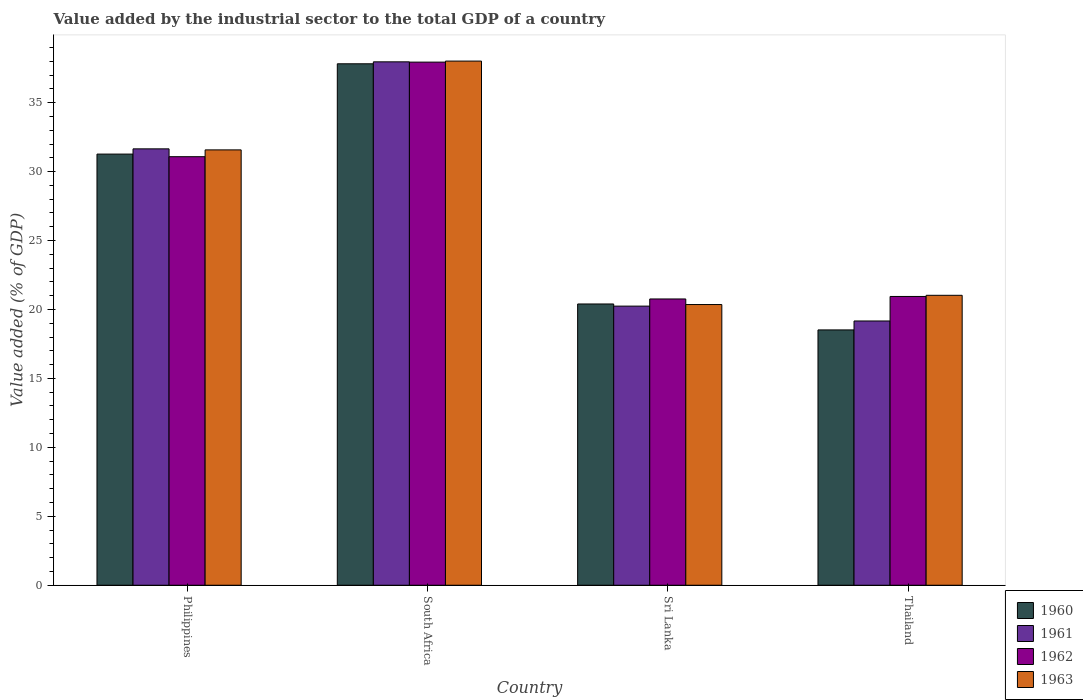How many different coloured bars are there?
Ensure brevity in your answer.  4. How many groups of bars are there?
Provide a succinct answer. 4. Are the number of bars per tick equal to the number of legend labels?
Offer a very short reply. Yes. Are the number of bars on each tick of the X-axis equal?
Your answer should be compact. Yes. What is the label of the 4th group of bars from the left?
Provide a succinct answer. Thailand. What is the value added by the industrial sector to the total GDP in 1962 in Thailand?
Offer a terse response. 20.94. Across all countries, what is the maximum value added by the industrial sector to the total GDP in 1963?
Your answer should be very brief. 38.01. Across all countries, what is the minimum value added by the industrial sector to the total GDP in 1963?
Your response must be concise. 20.36. In which country was the value added by the industrial sector to the total GDP in 1962 maximum?
Offer a very short reply. South Africa. In which country was the value added by the industrial sector to the total GDP in 1962 minimum?
Make the answer very short. Sri Lanka. What is the total value added by the industrial sector to the total GDP in 1963 in the graph?
Offer a terse response. 110.97. What is the difference between the value added by the industrial sector to the total GDP in 1960 in Philippines and that in South Africa?
Keep it short and to the point. -6.55. What is the difference between the value added by the industrial sector to the total GDP in 1960 in South Africa and the value added by the industrial sector to the total GDP in 1962 in Sri Lanka?
Offer a very short reply. 17.06. What is the average value added by the industrial sector to the total GDP in 1960 per country?
Offer a very short reply. 27. What is the difference between the value added by the industrial sector to the total GDP of/in 1962 and value added by the industrial sector to the total GDP of/in 1960 in Thailand?
Make the answer very short. 2.43. What is the ratio of the value added by the industrial sector to the total GDP in 1963 in South Africa to that in Thailand?
Offer a very short reply. 1.81. Is the value added by the industrial sector to the total GDP in 1960 in Philippines less than that in Sri Lanka?
Your response must be concise. No. Is the difference between the value added by the industrial sector to the total GDP in 1962 in Philippines and Thailand greater than the difference between the value added by the industrial sector to the total GDP in 1960 in Philippines and Thailand?
Offer a terse response. No. What is the difference between the highest and the second highest value added by the industrial sector to the total GDP in 1963?
Keep it short and to the point. -16.99. What is the difference between the highest and the lowest value added by the industrial sector to the total GDP in 1960?
Keep it short and to the point. 19.3. In how many countries, is the value added by the industrial sector to the total GDP in 1960 greater than the average value added by the industrial sector to the total GDP in 1960 taken over all countries?
Your answer should be very brief. 2. What does the 3rd bar from the right in Thailand represents?
Provide a short and direct response. 1961. Are all the bars in the graph horizontal?
Offer a very short reply. No. How many countries are there in the graph?
Offer a very short reply. 4. What is the difference between two consecutive major ticks on the Y-axis?
Your answer should be very brief. 5. Are the values on the major ticks of Y-axis written in scientific E-notation?
Offer a very short reply. No. Does the graph contain grids?
Ensure brevity in your answer.  No. How are the legend labels stacked?
Give a very brief answer. Vertical. What is the title of the graph?
Make the answer very short. Value added by the industrial sector to the total GDP of a country. Does "1968" appear as one of the legend labels in the graph?
Keep it short and to the point. No. What is the label or title of the X-axis?
Offer a very short reply. Country. What is the label or title of the Y-axis?
Give a very brief answer. Value added (% of GDP). What is the Value added (% of GDP) in 1960 in Philippines?
Provide a succinct answer. 31.27. What is the Value added (% of GDP) of 1961 in Philippines?
Offer a terse response. 31.65. What is the Value added (% of GDP) in 1962 in Philippines?
Offer a very short reply. 31.08. What is the Value added (% of GDP) of 1963 in Philippines?
Offer a terse response. 31.57. What is the Value added (% of GDP) of 1960 in South Africa?
Provide a succinct answer. 37.82. What is the Value added (% of GDP) of 1961 in South Africa?
Offer a very short reply. 37.96. What is the Value added (% of GDP) in 1962 in South Africa?
Provide a short and direct response. 37.94. What is the Value added (% of GDP) in 1963 in South Africa?
Provide a succinct answer. 38.01. What is the Value added (% of GDP) in 1960 in Sri Lanka?
Your answer should be very brief. 20.4. What is the Value added (% of GDP) of 1961 in Sri Lanka?
Your answer should be very brief. 20.24. What is the Value added (% of GDP) in 1962 in Sri Lanka?
Keep it short and to the point. 20.76. What is the Value added (% of GDP) in 1963 in Sri Lanka?
Keep it short and to the point. 20.36. What is the Value added (% of GDP) in 1960 in Thailand?
Keep it short and to the point. 18.52. What is the Value added (% of GDP) of 1961 in Thailand?
Make the answer very short. 19.16. What is the Value added (% of GDP) of 1962 in Thailand?
Offer a very short reply. 20.94. What is the Value added (% of GDP) in 1963 in Thailand?
Your answer should be very brief. 21.03. Across all countries, what is the maximum Value added (% of GDP) in 1960?
Ensure brevity in your answer.  37.82. Across all countries, what is the maximum Value added (% of GDP) of 1961?
Your answer should be very brief. 37.96. Across all countries, what is the maximum Value added (% of GDP) in 1962?
Your answer should be very brief. 37.94. Across all countries, what is the maximum Value added (% of GDP) in 1963?
Ensure brevity in your answer.  38.01. Across all countries, what is the minimum Value added (% of GDP) of 1960?
Provide a short and direct response. 18.52. Across all countries, what is the minimum Value added (% of GDP) of 1961?
Your response must be concise. 19.16. Across all countries, what is the minimum Value added (% of GDP) of 1962?
Give a very brief answer. 20.76. Across all countries, what is the minimum Value added (% of GDP) of 1963?
Ensure brevity in your answer.  20.36. What is the total Value added (% of GDP) in 1960 in the graph?
Offer a terse response. 108. What is the total Value added (% of GDP) in 1961 in the graph?
Provide a succinct answer. 109.02. What is the total Value added (% of GDP) in 1962 in the graph?
Your answer should be compact. 110.72. What is the total Value added (% of GDP) in 1963 in the graph?
Provide a short and direct response. 110.97. What is the difference between the Value added (% of GDP) of 1960 in Philippines and that in South Africa?
Keep it short and to the point. -6.55. What is the difference between the Value added (% of GDP) in 1961 in Philippines and that in South Africa?
Give a very brief answer. -6.31. What is the difference between the Value added (% of GDP) in 1962 in Philippines and that in South Africa?
Your answer should be compact. -6.86. What is the difference between the Value added (% of GDP) of 1963 in Philippines and that in South Africa?
Your answer should be very brief. -6.44. What is the difference between the Value added (% of GDP) in 1960 in Philippines and that in Sri Lanka?
Provide a succinct answer. 10.87. What is the difference between the Value added (% of GDP) in 1961 in Philippines and that in Sri Lanka?
Give a very brief answer. 11.41. What is the difference between the Value added (% of GDP) of 1962 in Philippines and that in Sri Lanka?
Provide a short and direct response. 10.32. What is the difference between the Value added (% of GDP) in 1963 in Philippines and that in Sri Lanka?
Your answer should be very brief. 11.22. What is the difference between the Value added (% of GDP) of 1960 in Philippines and that in Thailand?
Keep it short and to the point. 12.75. What is the difference between the Value added (% of GDP) in 1961 in Philippines and that in Thailand?
Your response must be concise. 12.48. What is the difference between the Value added (% of GDP) in 1962 in Philippines and that in Thailand?
Your response must be concise. 10.14. What is the difference between the Value added (% of GDP) of 1963 in Philippines and that in Thailand?
Ensure brevity in your answer.  10.55. What is the difference between the Value added (% of GDP) in 1960 in South Africa and that in Sri Lanka?
Provide a succinct answer. 17.42. What is the difference between the Value added (% of GDP) in 1961 in South Africa and that in Sri Lanka?
Provide a succinct answer. 17.72. What is the difference between the Value added (% of GDP) in 1962 in South Africa and that in Sri Lanka?
Offer a terse response. 17.18. What is the difference between the Value added (% of GDP) in 1963 in South Africa and that in Sri Lanka?
Keep it short and to the point. 17.66. What is the difference between the Value added (% of GDP) of 1960 in South Africa and that in Thailand?
Offer a terse response. 19.3. What is the difference between the Value added (% of GDP) of 1961 in South Africa and that in Thailand?
Offer a terse response. 18.79. What is the difference between the Value added (% of GDP) in 1962 in South Africa and that in Thailand?
Make the answer very short. 17. What is the difference between the Value added (% of GDP) in 1963 in South Africa and that in Thailand?
Offer a terse response. 16.99. What is the difference between the Value added (% of GDP) in 1960 in Sri Lanka and that in Thailand?
Your response must be concise. 1.88. What is the difference between the Value added (% of GDP) in 1961 in Sri Lanka and that in Thailand?
Offer a very short reply. 1.08. What is the difference between the Value added (% of GDP) in 1962 in Sri Lanka and that in Thailand?
Provide a succinct answer. -0.18. What is the difference between the Value added (% of GDP) in 1963 in Sri Lanka and that in Thailand?
Ensure brevity in your answer.  -0.67. What is the difference between the Value added (% of GDP) of 1960 in Philippines and the Value added (% of GDP) of 1961 in South Africa?
Provide a short and direct response. -6.69. What is the difference between the Value added (% of GDP) of 1960 in Philippines and the Value added (% of GDP) of 1962 in South Africa?
Make the answer very short. -6.67. What is the difference between the Value added (% of GDP) in 1960 in Philippines and the Value added (% of GDP) in 1963 in South Africa?
Offer a very short reply. -6.75. What is the difference between the Value added (% of GDP) in 1961 in Philippines and the Value added (% of GDP) in 1962 in South Africa?
Keep it short and to the point. -6.29. What is the difference between the Value added (% of GDP) of 1961 in Philippines and the Value added (% of GDP) of 1963 in South Africa?
Ensure brevity in your answer.  -6.37. What is the difference between the Value added (% of GDP) of 1962 in Philippines and the Value added (% of GDP) of 1963 in South Africa?
Offer a terse response. -6.93. What is the difference between the Value added (% of GDP) in 1960 in Philippines and the Value added (% of GDP) in 1961 in Sri Lanka?
Give a very brief answer. 11.03. What is the difference between the Value added (% of GDP) in 1960 in Philippines and the Value added (% of GDP) in 1962 in Sri Lanka?
Provide a succinct answer. 10.51. What is the difference between the Value added (% of GDP) of 1960 in Philippines and the Value added (% of GDP) of 1963 in Sri Lanka?
Give a very brief answer. 10.91. What is the difference between the Value added (% of GDP) of 1961 in Philippines and the Value added (% of GDP) of 1962 in Sri Lanka?
Keep it short and to the point. 10.89. What is the difference between the Value added (% of GDP) of 1961 in Philippines and the Value added (% of GDP) of 1963 in Sri Lanka?
Ensure brevity in your answer.  11.29. What is the difference between the Value added (% of GDP) in 1962 in Philippines and the Value added (% of GDP) in 1963 in Sri Lanka?
Offer a terse response. 10.72. What is the difference between the Value added (% of GDP) in 1960 in Philippines and the Value added (% of GDP) in 1961 in Thailand?
Provide a succinct answer. 12.1. What is the difference between the Value added (% of GDP) in 1960 in Philippines and the Value added (% of GDP) in 1962 in Thailand?
Your answer should be very brief. 10.33. What is the difference between the Value added (% of GDP) of 1960 in Philippines and the Value added (% of GDP) of 1963 in Thailand?
Your response must be concise. 10.24. What is the difference between the Value added (% of GDP) of 1961 in Philippines and the Value added (% of GDP) of 1962 in Thailand?
Provide a succinct answer. 10.71. What is the difference between the Value added (% of GDP) in 1961 in Philippines and the Value added (% of GDP) in 1963 in Thailand?
Offer a terse response. 10.62. What is the difference between the Value added (% of GDP) in 1962 in Philippines and the Value added (% of GDP) in 1963 in Thailand?
Keep it short and to the point. 10.05. What is the difference between the Value added (% of GDP) of 1960 in South Africa and the Value added (% of GDP) of 1961 in Sri Lanka?
Your answer should be compact. 17.57. What is the difference between the Value added (% of GDP) of 1960 in South Africa and the Value added (% of GDP) of 1962 in Sri Lanka?
Ensure brevity in your answer.  17.06. What is the difference between the Value added (% of GDP) in 1960 in South Africa and the Value added (% of GDP) in 1963 in Sri Lanka?
Offer a terse response. 17.46. What is the difference between the Value added (% of GDP) of 1961 in South Africa and the Value added (% of GDP) of 1962 in Sri Lanka?
Your answer should be compact. 17.2. What is the difference between the Value added (% of GDP) in 1961 in South Africa and the Value added (% of GDP) in 1963 in Sri Lanka?
Give a very brief answer. 17.6. What is the difference between the Value added (% of GDP) of 1962 in South Africa and the Value added (% of GDP) of 1963 in Sri Lanka?
Keep it short and to the point. 17.58. What is the difference between the Value added (% of GDP) in 1960 in South Africa and the Value added (% of GDP) in 1961 in Thailand?
Your answer should be very brief. 18.65. What is the difference between the Value added (% of GDP) of 1960 in South Africa and the Value added (% of GDP) of 1962 in Thailand?
Keep it short and to the point. 16.87. What is the difference between the Value added (% of GDP) of 1960 in South Africa and the Value added (% of GDP) of 1963 in Thailand?
Your answer should be very brief. 16.79. What is the difference between the Value added (% of GDP) of 1961 in South Africa and the Value added (% of GDP) of 1962 in Thailand?
Give a very brief answer. 17.02. What is the difference between the Value added (% of GDP) in 1961 in South Africa and the Value added (% of GDP) in 1963 in Thailand?
Keep it short and to the point. 16.93. What is the difference between the Value added (% of GDP) in 1962 in South Africa and the Value added (% of GDP) in 1963 in Thailand?
Provide a succinct answer. 16.91. What is the difference between the Value added (% of GDP) in 1960 in Sri Lanka and the Value added (% of GDP) in 1961 in Thailand?
Make the answer very short. 1.23. What is the difference between the Value added (% of GDP) of 1960 in Sri Lanka and the Value added (% of GDP) of 1962 in Thailand?
Make the answer very short. -0.54. What is the difference between the Value added (% of GDP) in 1960 in Sri Lanka and the Value added (% of GDP) in 1963 in Thailand?
Make the answer very short. -0.63. What is the difference between the Value added (% of GDP) of 1961 in Sri Lanka and the Value added (% of GDP) of 1962 in Thailand?
Your answer should be compact. -0.7. What is the difference between the Value added (% of GDP) of 1961 in Sri Lanka and the Value added (% of GDP) of 1963 in Thailand?
Give a very brief answer. -0.78. What is the difference between the Value added (% of GDP) in 1962 in Sri Lanka and the Value added (% of GDP) in 1963 in Thailand?
Give a very brief answer. -0.27. What is the average Value added (% of GDP) of 1960 per country?
Ensure brevity in your answer.  27. What is the average Value added (% of GDP) in 1961 per country?
Your answer should be compact. 27.25. What is the average Value added (% of GDP) of 1962 per country?
Offer a very short reply. 27.68. What is the average Value added (% of GDP) in 1963 per country?
Make the answer very short. 27.74. What is the difference between the Value added (% of GDP) of 1960 and Value added (% of GDP) of 1961 in Philippines?
Provide a short and direct response. -0.38. What is the difference between the Value added (% of GDP) in 1960 and Value added (% of GDP) in 1962 in Philippines?
Ensure brevity in your answer.  0.19. What is the difference between the Value added (% of GDP) in 1960 and Value added (% of GDP) in 1963 in Philippines?
Your answer should be compact. -0.3. What is the difference between the Value added (% of GDP) in 1961 and Value added (% of GDP) in 1962 in Philippines?
Your response must be concise. 0.57. What is the difference between the Value added (% of GDP) in 1961 and Value added (% of GDP) in 1963 in Philippines?
Offer a very short reply. 0.08. What is the difference between the Value added (% of GDP) of 1962 and Value added (% of GDP) of 1963 in Philippines?
Offer a terse response. -0.49. What is the difference between the Value added (% of GDP) in 1960 and Value added (% of GDP) in 1961 in South Africa?
Ensure brevity in your answer.  -0.14. What is the difference between the Value added (% of GDP) in 1960 and Value added (% of GDP) in 1962 in South Africa?
Keep it short and to the point. -0.12. What is the difference between the Value added (% of GDP) in 1960 and Value added (% of GDP) in 1963 in South Africa?
Offer a terse response. -0.2. What is the difference between the Value added (% of GDP) in 1961 and Value added (% of GDP) in 1962 in South Africa?
Provide a short and direct response. 0.02. What is the difference between the Value added (% of GDP) in 1961 and Value added (% of GDP) in 1963 in South Africa?
Your answer should be compact. -0.05. What is the difference between the Value added (% of GDP) of 1962 and Value added (% of GDP) of 1963 in South Africa?
Keep it short and to the point. -0.08. What is the difference between the Value added (% of GDP) of 1960 and Value added (% of GDP) of 1961 in Sri Lanka?
Offer a very short reply. 0.16. What is the difference between the Value added (% of GDP) of 1960 and Value added (% of GDP) of 1962 in Sri Lanka?
Your response must be concise. -0.36. What is the difference between the Value added (% of GDP) of 1960 and Value added (% of GDP) of 1963 in Sri Lanka?
Offer a terse response. 0.04. What is the difference between the Value added (% of GDP) of 1961 and Value added (% of GDP) of 1962 in Sri Lanka?
Your response must be concise. -0.52. What is the difference between the Value added (% of GDP) of 1961 and Value added (% of GDP) of 1963 in Sri Lanka?
Provide a succinct answer. -0.11. What is the difference between the Value added (% of GDP) of 1962 and Value added (% of GDP) of 1963 in Sri Lanka?
Provide a short and direct response. 0.4. What is the difference between the Value added (% of GDP) of 1960 and Value added (% of GDP) of 1961 in Thailand?
Offer a terse response. -0.65. What is the difference between the Value added (% of GDP) of 1960 and Value added (% of GDP) of 1962 in Thailand?
Your answer should be very brief. -2.43. What is the difference between the Value added (% of GDP) in 1960 and Value added (% of GDP) in 1963 in Thailand?
Provide a short and direct response. -2.51. What is the difference between the Value added (% of GDP) of 1961 and Value added (% of GDP) of 1962 in Thailand?
Keep it short and to the point. -1.78. What is the difference between the Value added (% of GDP) of 1961 and Value added (% of GDP) of 1963 in Thailand?
Your answer should be compact. -1.86. What is the difference between the Value added (% of GDP) of 1962 and Value added (% of GDP) of 1963 in Thailand?
Provide a succinct answer. -0.08. What is the ratio of the Value added (% of GDP) of 1960 in Philippines to that in South Africa?
Keep it short and to the point. 0.83. What is the ratio of the Value added (% of GDP) in 1961 in Philippines to that in South Africa?
Provide a short and direct response. 0.83. What is the ratio of the Value added (% of GDP) in 1962 in Philippines to that in South Africa?
Provide a short and direct response. 0.82. What is the ratio of the Value added (% of GDP) in 1963 in Philippines to that in South Africa?
Provide a succinct answer. 0.83. What is the ratio of the Value added (% of GDP) in 1960 in Philippines to that in Sri Lanka?
Provide a short and direct response. 1.53. What is the ratio of the Value added (% of GDP) of 1961 in Philippines to that in Sri Lanka?
Offer a terse response. 1.56. What is the ratio of the Value added (% of GDP) of 1962 in Philippines to that in Sri Lanka?
Keep it short and to the point. 1.5. What is the ratio of the Value added (% of GDP) of 1963 in Philippines to that in Sri Lanka?
Offer a terse response. 1.55. What is the ratio of the Value added (% of GDP) in 1960 in Philippines to that in Thailand?
Keep it short and to the point. 1.69. What is the ratio of the Value added (% of GDP) of 1961 in Philippines to that in Thailand?
Offer a very short reply. 1.65. What is the ratio of the Value added (% of GDP) in 1962 in Philippines to that in Thailand?
Provide a short and direct response. 1.48. What is the ratio of the Value added (% of GDP) of 1963 in Philippines to that in Thailand?
Give a very brief answer. 1.5. What is the ratio of the Value added (% of GDP) in 1960 in South Africa to that in Sri Lanka?
Your answer should be compact. 1.85. What is the ratio of the Value added (% of GDP) in 1961 in South Africa to that in Sri Lanka?
Make the answer very short. 1.88. What is the ratio of the Value added (% of GDP) in 1962 in South Africa to that in Sri Lanka?
Your answer should be very brief. 1.83. What is the ratio of the Value added (% of GDP) in 1963 in South Africa to that in Sri Lanka?
Offer a terse response. 1.87. What is the ratio of the Value added (% of GDP) of 1960 in South Africa to that in Thailand?
Your answer should be compact. 2.04. What is the ratio of the Value added (% of GDP) of 1961 in South Africa to that in Thailand?
Make the answer very short. 1.98. What is the ratio of the Value added (% of GDP) in 1962 in South Africa to that in Thailand?
Provide a succinct answer. 1.81. What is the ratio of the Value added (% of GDP) in 1963 in South Africa to that in Thailand?
Make the answer very short. 1.81. What is the ratio of the Value added (% of GDP) in 1960 in Sri Lanka to that in Thailand?
Your answer should be compact. 1.1. What is the ratio of the Value added (% of GDP) of 1961 in Sri Lanka to that in Thailand?
Give a very brief answer. 1.06. What is the ratio of the Value added (% of GDP) in 1963 in Sri Lanka to that in Thailand?
Provide a short and direct response. 0.97. What is the difference between the highest and the second highest Value added (% of GDP) in 1960?
Ensure brevity in your answer.  6.55. What is the difference between the highest and the second highest Value added (% of GDP) of 1961?
Offer a terse response. 6.31. What is the difference between the highest and the second highest Value added (% of GDP) in 1962?
Your answer should be compact. 6.86. What is the difference between the highest and the second highest Value added (% of GDP) in 1963?
Give a very brief answer. 6.44. What is the difference between the highest and the lowest Value added (% of GDP) in 1960?
Your response must be concise. 19.3. What is the difference between the highest and the lowest Value added (% of GDP) in 1961?
Keep it short and to the point. 18.79. What is the difference between the highest and the lowest Value added (% of GDP) in 1962?
Offer a terse response. 17.18. What is the difference between the highest and the lowest Value added (% of GDP) of 1963?
Your answer should be compact. 17.66. 